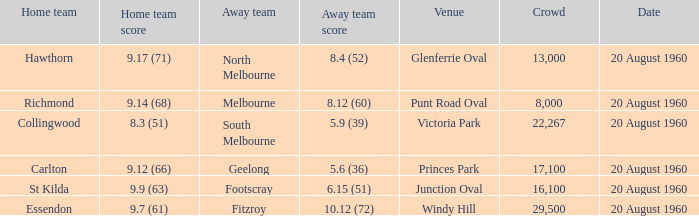What is the crowd size of the game when Fitzroy is the away team? 1.0. Could you parse the entire table as a dict? {'header': ['Home team', 'Home team score', 'Away team', 'Away team score', 'Venue', 'Crowd', 'Date'], 'rows': [['Hawthorn', '9.17 (71)', 'North Melbourne', '8.4 (52)', 'Glenferrie Oval', '13,000', '20 August 1960'], ['Richmond', '9.14 (68)', 'Melbourne', '8.12 (60)', 'Punt Road Oval', '8,000', '20 August 1960'], ['Collingwood', '8.3 (51)', 'South Melbourne', '5.9 (39)', 'Victoria Park', '22,267', '20 August 1960'], ['Carlton', '9.12 (66)', 'Geelong', '5.6 (36)', 'Princes Park', '17,100', '20 August 1960'], ['St Kilda', '9.9 (63)', 'Footscray', '6.15 (51)', 'Junction Oval', '16,100', '20 August 1960'], ['Essendon', '9.7 (61)', 'Fitzroy', '10.12 (72)', 'Windy Hill', '29,500', '20 August 1960']]} 